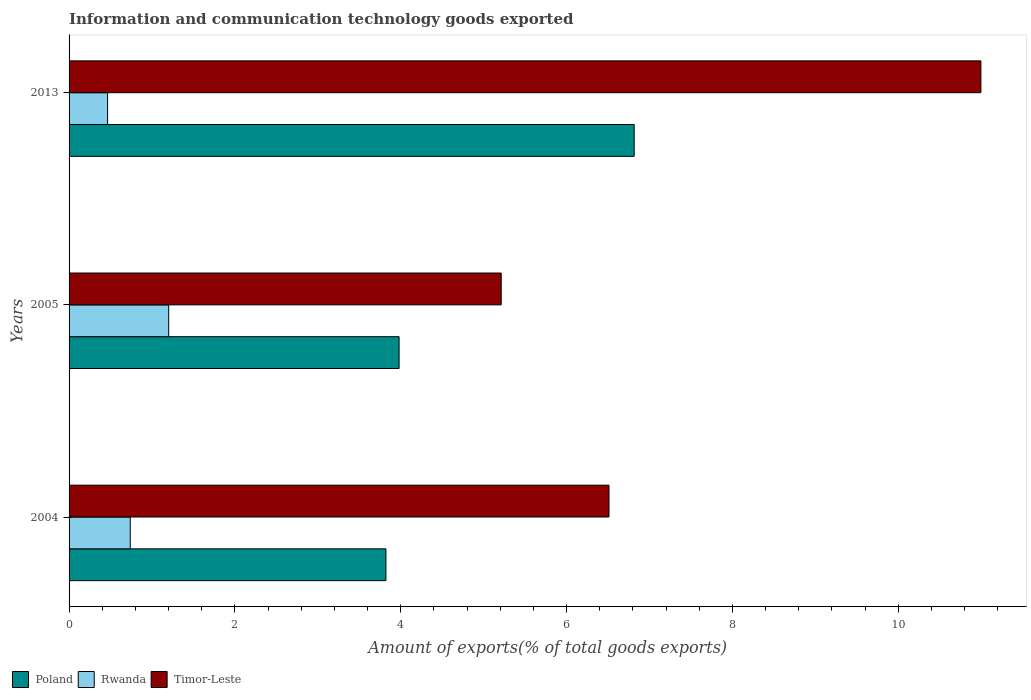How many different coloured bars are there?
Your response must be concise. 3. Are the number of bars on each tick of the Y-axis equal?
Give a very brief answer. Yes. How many bars are there on the 2nd tick from the top?
Your answer should be compact. 3. How many bars are there on the 3rd tick from the bottom?
Make the answer very short. 3. What is the label of the 1st group of bars from the top?
Your answer should be compact. 2013. In how many cases, is the number of bars for a given year not equal to the number of legend labels?
Make the answer very short. 0. What is the amount of goods exported in Rwanda in 2005?
Your response must be concise. 1.2. Across all years, what is the maximum amount of goods exported in Timor-Leste?
Give a very brief answer. 11. Across all years, what is the minimum amount of goods exported in Poland?
Offer a terse response. 3.82. In which year was the amount of goods exported in Timor-Leste maximum?
Provide a succinct answer. 2013. In which year was the amount of goods exported in Poland minimum?
Provide a short and direct response. 2004. What is the total amount of goods exported in Rwanda in the graph?
Provide a short and direct response. 2.4. What is the difference between the amount of goods exported in Timor-Leste in 2004 and that in 2013?
Provide a short and direct response. -4.49. What is the difference between the amount of goods exported in Timor-Leste in 2005 and the amount of goods exported in Poland in 2013?
Provide a succinct answer. -1.6. What is the average amount of goods exported in Timor-Leste per year?
Ensure brevity in your answer.  7.57. In the year 2005, what is the difference between the amount of goods exported in Timor-Leste and amount of goods exported in Poland?
Your answer should be compact. 1.23. In how many years, is the amount of goods exported in Poland greater than 8 %?
Your answer should be compact. 0. What is the ratio of the amount of goods exported in Poland in 2004 to that in 2005?
Provide a short and direct response. 0.96. Is the amount of goods exported in Rwanda in 2004 less than that in 2013?
Offer a very short reply. No. What is the difference between the highest and the second highest amount of goods exported in Poland?
Offer a terse response. 2.84. What is the difference between the highest and the lowest amount of goods exported in Rwanda?
Ensure brevity in your answer.  0.74. What does the 1st bar from the top in 2004 represents?
Ensure brevity in your answer.  Timor-Leste. What does the 3rd bar from the bottom in 2005 represents?
Offer a very short reply. Timor-Leste. Is it the case that in every year, the sum of the amount of goods exported in Rwanda and amount of goods exported in Poland is greater than the amount of goods exported in Timor-Leste?
Your response must be concise. No. Are all the bars in the graph horizontal?
Your answer should be very brief. Yes. Does the graph contain any zero values?
Provide a succinct answer. No. Does the graph contain grids?
Give a very brief answer. No. Where does the legend appear in the graph?
Provide a short and direct response. Bottom left. How many legend labels are there?
Give a very brief answer. 3. What is the title of the graph?
Give a very brief answer. Information and communication technology goods exported. What is the label or title of the X-axis?
Offer a terse response. Amount of exports(% of total goods exports). What is the Amount of exports(% of total goods exports) in Poland in 2004?
Provide a short and direct response. 3.82. What is the Amount of exports(% of total goods exports) in Rwanda in 2004?
Provide a short and direct response. 0.74. What is the Amount of exports(% of total goods exports) in Timor-Leste in 2004?
Your answer should be very brief. 6.51. What is the Amount of exports(% of total goods exports) in Poland in 2005?
Make the answer very short. 3.98. What is the Amount of exports(% of total goods exports) in Rwanda in 2005?
Ensure brevity in your answer.  1.2. What is the Amount of exports(% of total goods exports) in Timor-Leste in 2005?
Your answer should be very brief. 5.21. What is the Amount of exports(% of total goods exports) of Poland in 2013?
Offer a very short reply. 6.82. What is the Amount of exports(% of total goods exports) of Rwanda in 2013?
Make the answer very short. 0.46. What is the Amount of exports(% of total goods exports) in Timor-Leste in 2013?
Ensure brevity in your answer.  11. Across all years, what is the maximum Amount of exports(% of total goods exports) in Poland?
Give a very brief answer. 6.82. Across all years, what is the maximum Amount of exports(% of total goods exports) of Rwanda?
Keep it short and to the point. 1.2. Across all years, what is the maximum Amount of exports(% of total goods exports) of Timor-Leste?
Your response must be concise. 11. Across all years, what is the minimum Amount of exports(% of total goods exports) of Poland?
Offer a very short reply. 3.82. Across all years, what is the minimum Amount of exports(% of total goods exports) in Rwanda?
Your response must be concise. 0.46. Across all years, what is the minimum Amount of exports(% of total goods exports) in Timor-Leste?
Your answer should be very brief. 5.21. What is the total Amount of exports(% of total goods exports) in Poland in the graph?
Your answer should be compact. 14.62. What is the total Amount of exports(% of total goods exports) in Rwanda in the graph?
Your answer should be compact. 2.4. What is the total Amount of exports(% of total goods exports) in Timor-Leste in the graph?
Offer a very short reply. 22.72. What is the difference between the Amount of exports(% of total goods exports) of Poland in 2004 and that in 2005?
Make the answer very short. -0.16. What is the difference between the Amount of exports(% of total goods exports) in Rwanda in 2004 and that in 2005?
Ensure brevity in your answer.  -0.46. What is the difference between the Amount of exports(% of total goods exports) in Timor-Leste in 2004 and that in 2005?
Provide a short and direct response. 1.3. What is the difference between the Amount of exports(% of total goods exports) of Poland in 2004 and that in 2013?
Give a very brief answer. -2.99. What is the difference between the Amount of exports(% of total goods exports) of Rwanda in 2004 and that in 2013?
Provide a short and direct response. 0.27. What is the difference between the Amount of exports(% of total goods exports) of Timor-Leste in 2004 and that in 2013?
Your answer should be compact. -4.49. What is the difference between the Amount of exports(% of total goods exports) of Poland in 2005 and that in 2013?
Offer a terse response. -2.84. What is the difference between the Amount of exports(% of total goods exports) in Rwanda in 2005 and that in 2013?
Provide a short and direct response. 0.74. What is the difference between the Amount of exports(% of total goods exports) in Timor-Leste in 2005 and that in 2013?
Offer a very short reply. -5.79. What is the difference between the Amount of exports(% of total goods exports) of Poland in 2004 and the Amount of exports(% of total goods exports) of Rwanda in 2005?
Give a very brief answer. 2.62. What is the difference between the Amount of exports(% of total goods exports) in Poland in 2004 and the Amount of exports(% of total goods exports) in Timor-Leste in 2005?
Offer a very short reply. -1.39. What is the difference between the Amount of exports(% of total goods exports) in Rwanda in 2004 and the Amount of exports(% of total goods exports) in Timor-Leste in 2005?
Ensure brevity in your answer.  -4.47. What is the difference between the Amount of exports(% of total goods exports) in Poland in 2004 and the Amount of exports(% of total goods exports) in Rwanda in 2013?
Give a very brief answer. 3.36. What is the difference between the Amount of exports(% of total goods exports) in Poland in 2004 and the Amount of exports(% of total goods exports) in Timor-Leste in 2013?
Provide a short and direct response. -7.18. What is the difference between the Amount of exports(% of total goods exports) of Rwanda in 2004 and the Amount of exports(% of total goods exports) of Timor-Leste in 2013?
Offer a very short reply. -10.26. What is the difference between the Amount of exports(% of total goods exports) of Poland in 2005 and the Amount of exports(% of total goods exports) of Rwanda in 2013?
Offer a very short reply. 3.52. What is the difference between the Amount of exports(% of total goods exports) of Poland in 2005 and the Amount of exports(% of total goods exports) of Timor-Leste in 2013?
Your answer should be very brief. -7.02. What is the difference between the Amount of exports(% of total goods exports) in Rwanda in 2005 and the Amount of exports(% of total goods exports) in Timor-Leste in 2013?
Make the answer very short. -9.8. What is the average Amount of exports(% of total goods exports) of Poland per year?
Provide a succinct answer. 4.87. What is the average Amount of exports(% of total goods exports) in Rwanda per year?
Make the answer very short. 0.8. What is the average Amount of exports(% of total goods exports) of Timor-Leste per year?
Keep it short and to the point. 7.57. In the year 2004, what is the difference between the Amount of exports(% of total goods exports) in Poland and Amount of exports(% of total goods exports) in Rwanda?
Your response must be concise. 3.08. In the year 2004, what is the difference between the Amount of exports(% of total goods exports) of Poland and Amount of exports(% of total goods exports) of Timor-Leste?
Offer a very short reply. -2.69. In the year 2004, what is the difference between the Amount of exports(% of total goods exports) of Rwanda and Amount of exports(% of total goods exports) of Timor-Leste?
Offer a very short reply. -5.77. In the year 2005, what is the difference between the Amount of exports(% of total goods exports) of Poland and Amount of exports(% of total goods exports) of Rwanda?
Ensure brevity in your answer.  2.78. In the year 2005, what is the difference between the Amount of exports(% of total goods exports) in Poland and Amount of exports(% of total goods exports) in Timor-Leste?
Offer a very short reply. -1.23. In the year 2005, what is the difference between the Amount of exports(% of total goods exports) in Rwanda and Amount of exports(% of total goods exports) in Timor-Leste?
Offer a very short reply. -4.01. In the year 2013, what is the difference between the Amount of exports(% of total goods exports) of Poland and Amount of exports(% of total goods exports) of Rwanda?
Offer a very short reply. 6.35. In the year 2013, what is the difference between the Amount of exports(% of total goods exports) in Poland and Amount of exports(% of total goods exports) in Timor-Leste?
Provide a short and direct response. -4.18. In the year 2013, what is the difference between the Amount of exports(% of total goods exports) of Rwanda and Amount of exports(% of total goods exports) of Timor-Leste?
Your answer should be very brief. -10.53. What is the ratio of the Amount of exports(% of total goods exports) of Poland in 2004 to that in 2005?
Your response must be concise. 0.96. What is the ratio of the Amount of exports(% of total goods exports) in Rwanda in 2004 to that in 2005?
Your response must be concise. 0.61. What is the ratio of the Amount of exports(% of total goods exports) of Timor-Leste in 2004 to that in 2005?
Your answer should be compact. 1.25. What is the ratio of the Amount of exports(% of total goods exports) in Poland in 2004 to that in 2013?
Ensure brevity in your answer.  0.56. What is the ratio of the Amount of exports(% of total goods exports) in Rwanda in 2004 to that in 2013?
Keep it short and to the point. 1.59. What is the ratio of the Amount of exports(% of total goods exports) of Timor-Leste in 2004 to that in 2013?
Your answer should be very brief. 0.59. What is the ratio of the Amount of exports(% of total goods exports) in Poland in 2005 to that in 2013?
Your answer should be very brief. 0.58. What is the ratio of the Amount of exports(% of total goods exports) in Rwanda in 2005 to that in 2013?
Keep it short and to the point. 2.59. What is the ratio of the Amount of exports(% of total goods exports) of Timor-Leste in 2005 to that in 2013?
Your answer should be very brief. 0.47. What is the difference between the highest and the second highest Amount of exports(% of total goods exports) of Poland?
Keep it short and to the point. 2.84. What is the difference between the highest and the second highest Amount of exports(% of total goods exports) of Rwanda?
Ensure brevity in your answer.  0.46. What is the difference between the highest and the second highest Amount of exports(% of total goods exports) of Timor-Leste?
Ensure brevity in your answer.  4.49. What is the difference between the highest and the lowest Amount of exports(% of total goods exports) in Poland?
Offer a very short reply. 2.99. What is the difference between the highest and the lowest Amount of exports(% of total goods exports) in Rwanda?
Keep it short and to the point. 0.74. What is the difference between the highest and the lowest Amount of exports(% of total goods exports) in Timor-Leste?
Ensure brevity in your answer.  5.79. 